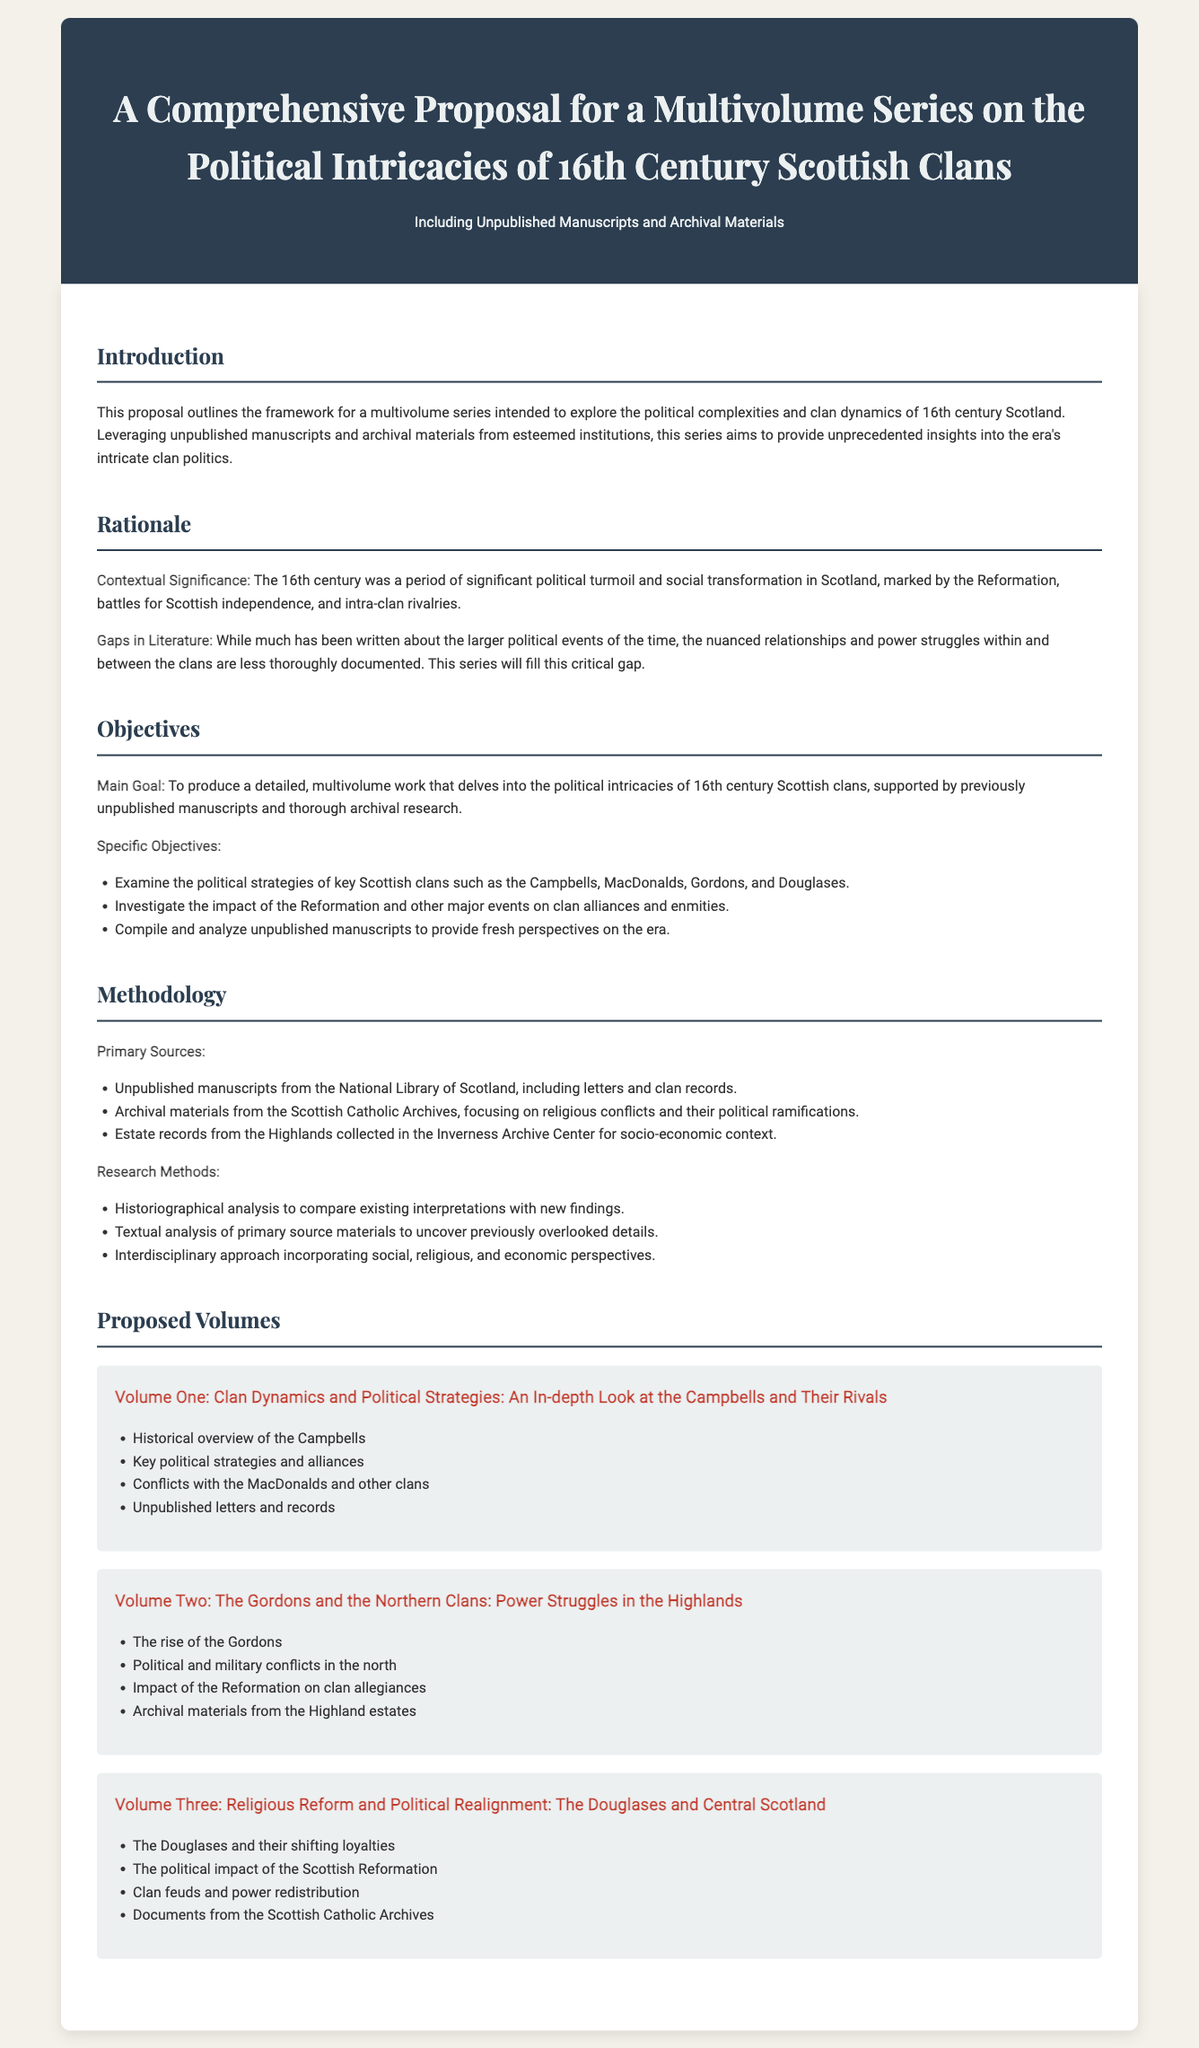What is the main goal of the proposal? The main goal is to produce a detailed, multivolume work that delves into the political intricacies of 16th century Scottish clans.
Answer: To produce a detailed, multivolume work What historical period does the proposal focus on? The proposal focuses on the political complexities and clan dynamics of the 16th century in Scotland.
Answer: 16th century Which clans are specifically mentioned in the objectives? The objectives mention the Campbells, MacDonalds, Gordons, and Douglases as key Scottish clans.
Answer: Campbells, MacDonalds, Gordons, and Douglases What type of materials will the research utilize? The research will utilize unpublished manuscripts and archival materials from esteemed institutions.
Answer: Unpublished manuscripts and archival materials How many proposed volumes are detailed in the document? The document outlines three proposed volumes in the series.
Answer: Three What is included in Volume One? Volume One includes historical overview of the Campbells, key political strategies, and conflicts with the MacDonalds.
Answer: Historical overview, key political strategies, conflicts Which archives are mentioned for primary sources? The primary sources include the National Library of Scotland, Scottish Catholic Archives, and the Inverness Archive Center.
Answer: National Library of Scotland, Scottish Catholic Archives, Inverness Archive Center What impact is investigated in Volume Two? Volume Two investigates the impact of the Reformation on clan allegiances.
Answer: Impact of the Reformation on clan allegiances What is the focus of the methodology section? The methodology section focuses on the types of primary sources and research methods employed in the study.
Answer: Types of primary sources and research methods 